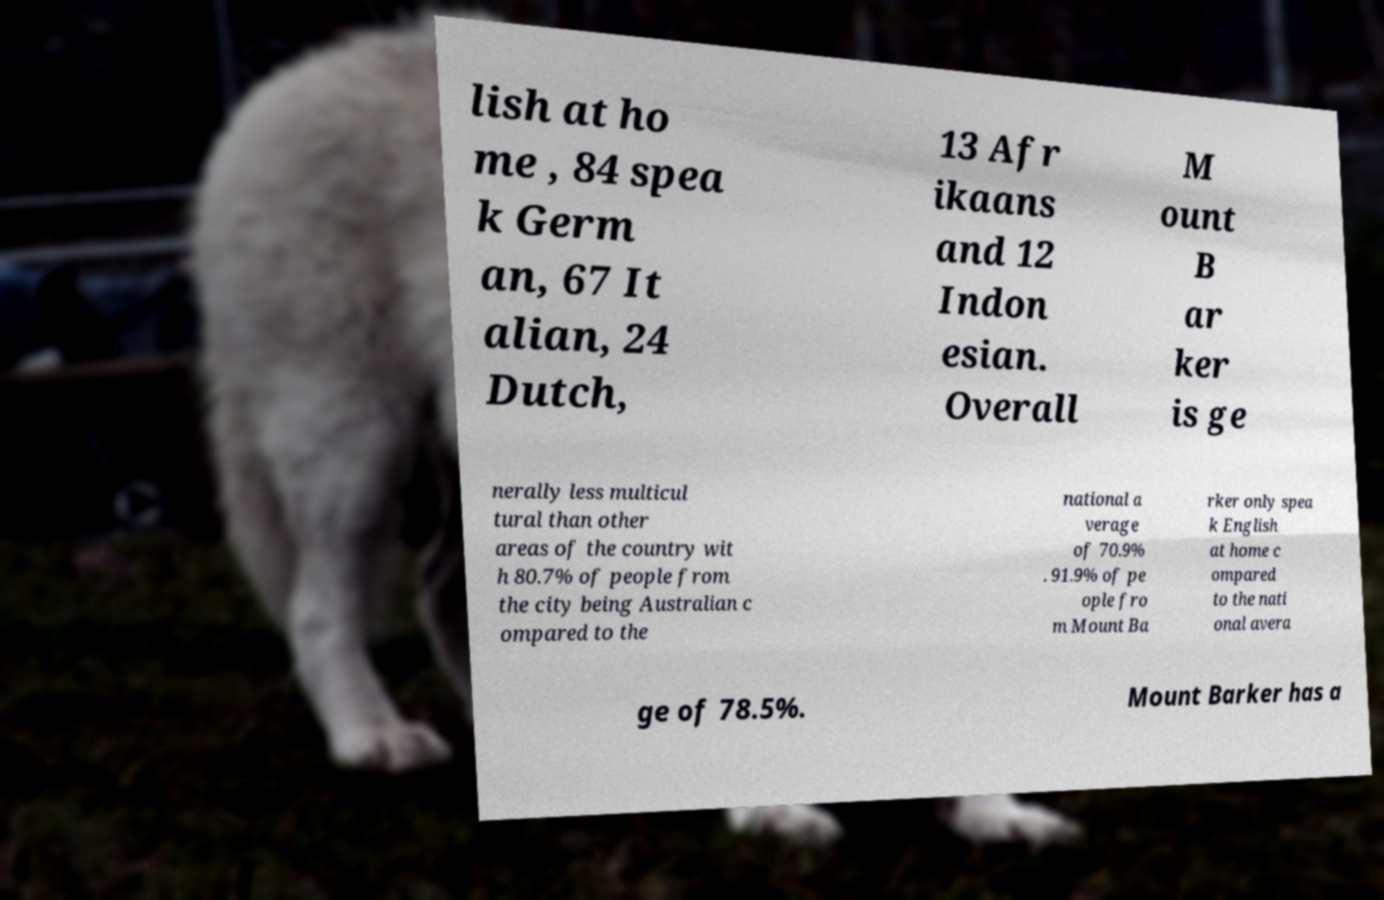Could you extract and type out the text from this image? lish at ho me , 84 spea k Germ an, 67 It alian, 24 Dutch, 13 Afr ikaans and 12 Indon esian. Overall M ount B ar ker is ge nerally less multicul tural than other areas of the country wit h 80.7% of people from the city being Australian c ompared to the national a verage of 70.9% . 91.9% of pe ople fro m Mount Ba rker only spea k English at home c ompared to the nati onal avera ge of 78.5%. Mount Barker has a 